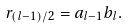Convert formula to latex. <formula><loc_0><loc_0><loc_500><loc_500>r _ { ( l - 1 ) / 2 } = a _ { l - 1 } b _ { l } .</formula> 